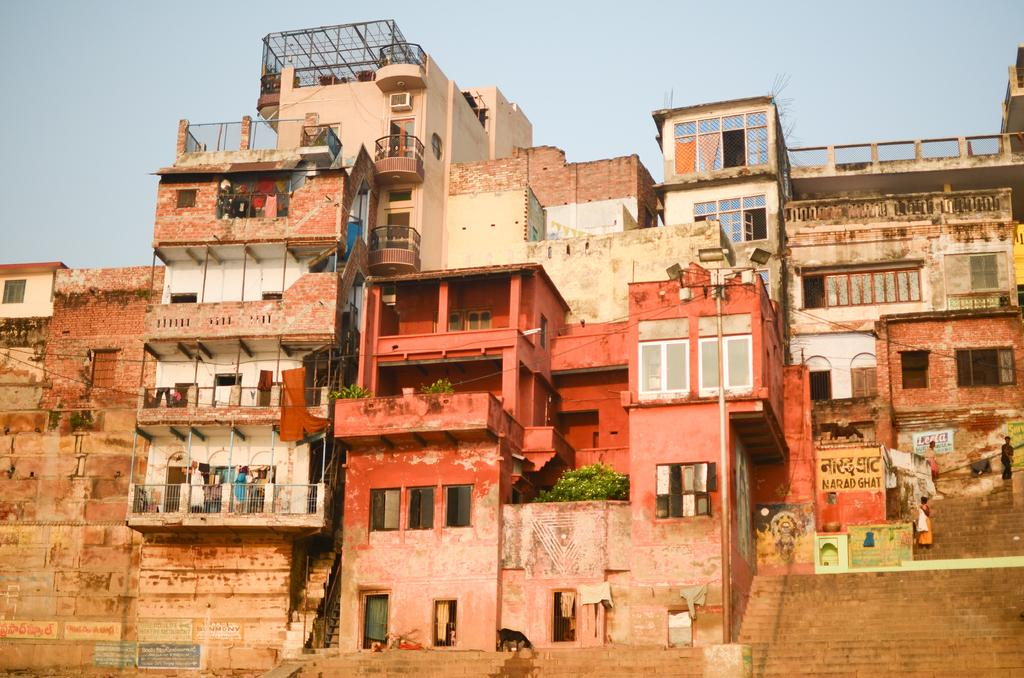What is located in the middle of the image? There are buildings in the middle of the image. What is on the buildings? There are plants on the buildings. What can be seen behind the buildings? The sky is visible behind the buildings. What type of nose can be seen on the frog in the image? There is no frog present in the image, so it is not possible to determine what type of nose might be seen on a frog. 